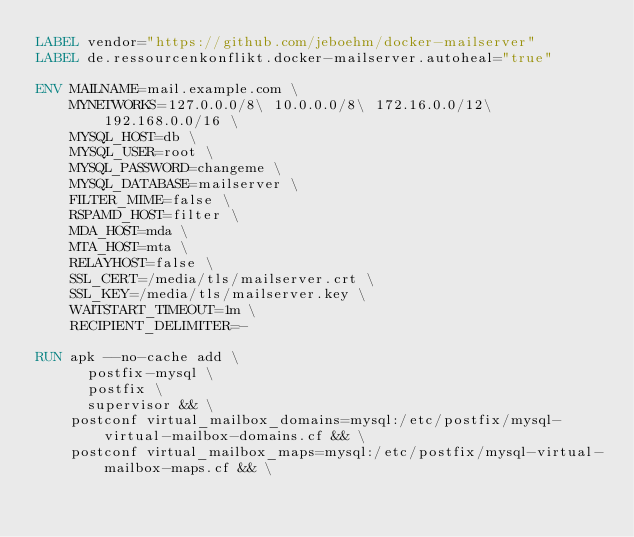Convert code to text. <code><loc_0><loc_0><loc_500><loc_500><_Dockerfile_>LABEL vendor="https://github.com/jeboehm/docker-mailserver"
LABEL de.ressourcenkonflikt.docker-mailserver.autoheal="true"

ENV MAILNAME=mail.example.com \
    MYNETWORKS=127.0.0.0/8\ 10.0.0.0/8\ 172.16.0.0/12\ 192.168.0.0/16 \
    MYSQL_HOST=db \
    MYSQL_USER=root \
    MYSQL_PASSWORD=changeme \
    MYSQL_DATABASE=mailserver \
    FILTER_MIME=false \
    RSPAMD_HOST=filter \
    MDA_HOST=mda \
    MTA_HOST=mta \
    RELAYHOST=false \
    SSL_CERT=/media/tls/mailserver.crt \
    SSL_KEY=/media/tls/mailserver.key \
    WAITSTART_TIMEOUT=1m \
    RECIPIENT_DELIMITER=-

RUN apk --no-cache add \
      postfix-mysql \
      postfix \
      supervisor && \
    postconf virtual_mailbox_domains=mysql:/etc/postfix/mysql-virtual-mailbox-domains.cf && \
    postconf virtual_mailbox_maps=mysql:/etc/postfix/mysql-virtual-mailbox-maps.cf && \</code> 